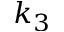Convert formula to latex. <formula><loc_0><loc_0><loc_500><loc_500>k _ { 3 }</formula> 